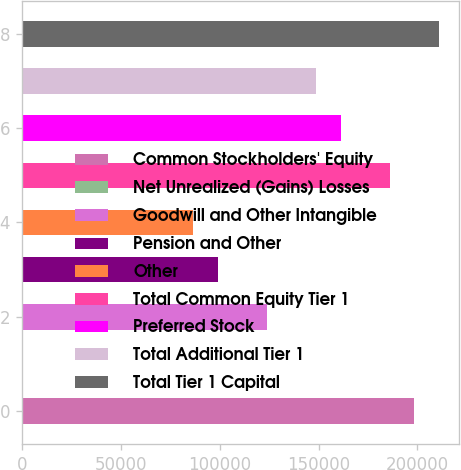Convert chart. <chart><loc_0><loc_0><loc_500><loc_500><bar_chart><fcel>Common Stockholders' Equity<fcel>Net Unrealized (Gains) Losses<fcel>Goodwill and Other Intangible<fcel>Pension and Other<fcel>Other<fcel>Total Common Equity Tier 1<fcel>Preferred Stock<fcel>Total Additional Tier 1<fcel>Total Tier 1 Capital<nl><fcel>198282<fcel>2.4<fcel>123927<fcel>99142<fcel>86749.6<fcel>185889<fcel>161104<fcel>148712<fcel>210674<nl></chart> 